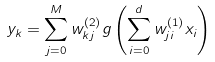<formula> <loc_0><loc_0><loc_500><loc_500>y _ { k } = \sum ^ { M } _ { j = 0 } w ^ { ( 2 ) } _ { k j } g \left ( \sum _ { i = 0 } ^ { d } w _ { j i } ^ { ( 1 ) } x _ { i } \right )</formula> 